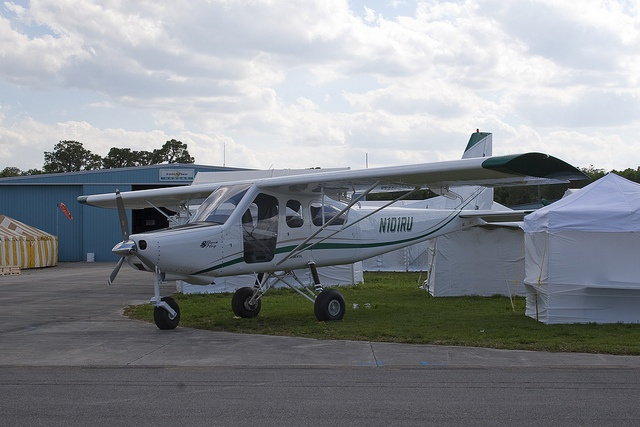Describe the objects in this image and their specific colors. I can see a airplane in darkgray, gray, and black tones in this image. 